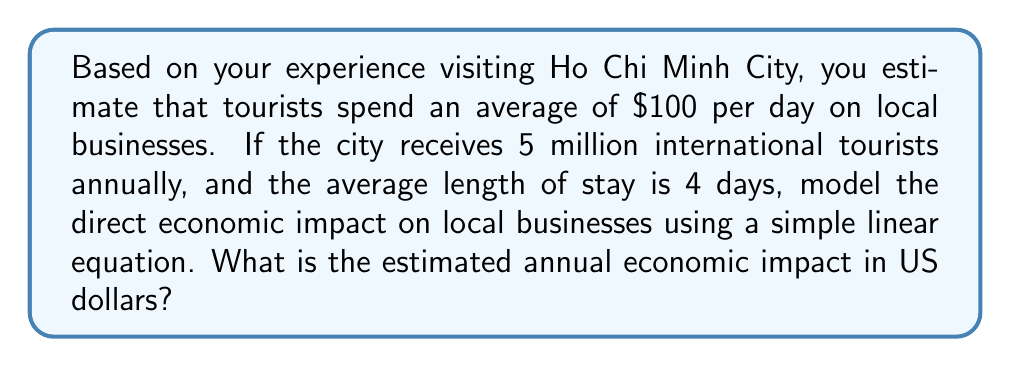Could you help me with this problem? Let's approach this step-by-step:

1) Define variables:
   $S$ = average daily spending per tourist
   $T$ = number of annual tourists
   $D$ = average length of stay in days
   $I$ = annual economic impact

2) Given information:
   $S = 100$ (dollars)
   $T = 5,000,000$ (tourists)
   $D = 4$ (days)

3) The linear model for economic impact can be expressed as:
   $$ I = S \times T \times D $$

4) Substitute the known values:
   $$ I = 100 \times 5,000,000 \times 4 $$

5) Calculate:
   $$ I = 2,000,000,000 $$

Therefore, the estimated annual economic impact on local businesses in Ho Chi Minh City is $2 billion.
Answer: $2 billion 